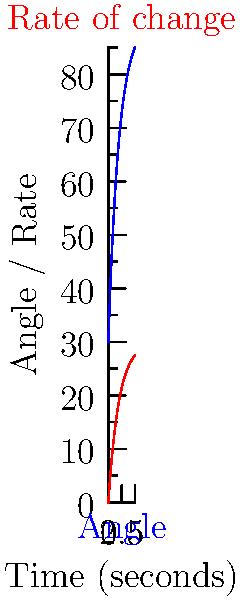As you adjust a mannequin's arm for an exhibition, the angle $\theta$ (in degrees) of the arm from its initial position is given by the function $\theta(t) = 90 - 60e^{-0.5t}$, where $t$ is the time in seconds. At what time does the rate of change of the arm's angle equal 10 degrees per second? To solve this problem, we need to follow these steps:

1) First, we need to find the rate of change of the arm's angle. This is given by the derivative of $\theta(t)$ with respect to $t$:

   $$\frac{d\theta}{dt} = \frac{d}{dt}(90 - 60e^{-0.5t}) = 30e^{-0.5t}$$

2) Now, we need to find at what time this rate of change equals 10 degrees per second:

   $$30e^{-0.5t} = 10$$

3) We can solve this equation for $t$:

   $$e^{-0.5t} = \frac{1}{3}$$

4) Taking the natural logarithm of both sides:

   $$-0.5t = \ln(\frac{1}{3})$$

5) Solving for $t$:

   $$t = -2\ln(\frac{1}{3}) = 2\ln(3)$$

6) Using a calculator or approximating:

   $$t \approx 2.197 \text{ seconds}$$

Therefore, the rate of change of the arm's angle equals 10 degrees per second after approximately 2.197 seconds.
Answer: $2\ln(3)$ seconds (≈ 2.197 seconds) 